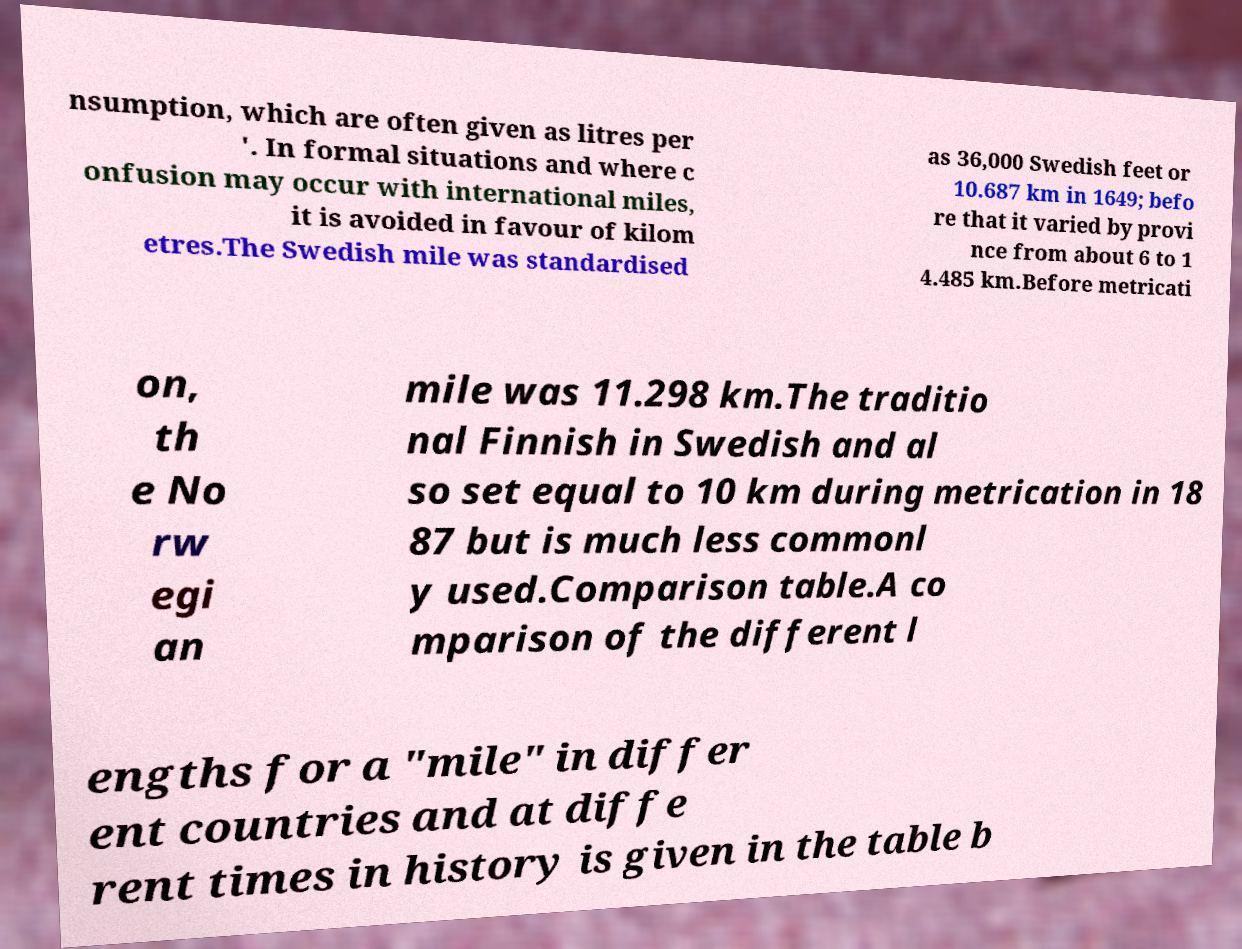Could you assist in decoding the text presented in this image and type it out clearly? nsumption, which are often given as litres per '. In formal situations and where c onfusion may occur with international miles, it is avoided in favour of kilom etres.The Swedish mile was standardised as 36,000 Swedish feet or 10.687 km in 1649; befo re that it varied by provi nce from about 6 to 1 4.485 km.Before metricati on, th e No rw egi an mile was 11.298 km.The traditio nal Finnish in Swedish and al so set equal to 10 km during metrication in 18 87 but is much less commonl y used.Comparison table.A co mparison of the different l engths for a "mile" in differ ent countries and at diffe rent times in history is given in the table b 